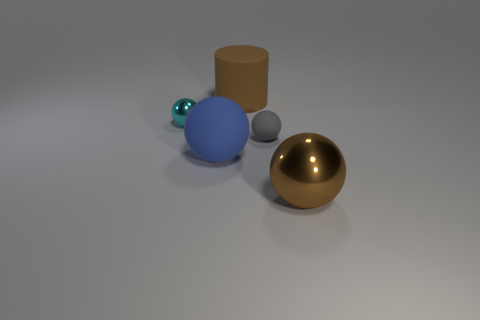Does the cylinder that is on the right side of the tiny cyan shiny object have the same material as the tiny gray ball?
Your response must be concise. Yes. There is a metal object right of the big brown object that is behind the metallic thing to the right of the small gray rubber object; what shape is it?
Your answer should be very brief. Sphere. Are there an equal number of gray things that are behind the cyan object and gray spheres that are in front of the large matte cylinder?
Ensure brevity in your answer.  No. The metallic object that is the same size as the brown rubber cylinder is what color?
Ensure brevity in your answer.  Brown. How many large things are brown shiny balls or cyan objects?
Your answer should be very brief. 1. There is a ball that is both behind the blue matte sphere and to the left of the rubber cylinder; what is it made of?
Offer a very short reply. Metal. There is a big brown thing that is behind the tiny metallic object; is it the same shape as the small thing that is in front of the tiny cyan shiny object?
Your response must be concise. No. What shape is the thing that is the same color as the cylinder?
Give a very brief answer. Sphere. How many things are either big brown objects behind the small metallic ball or brown matte cylinders?
Keep it short and to the point. 1. Does the cyan shiny object have the same size as the brown rubber thing?
Your answer should be compact. No. 